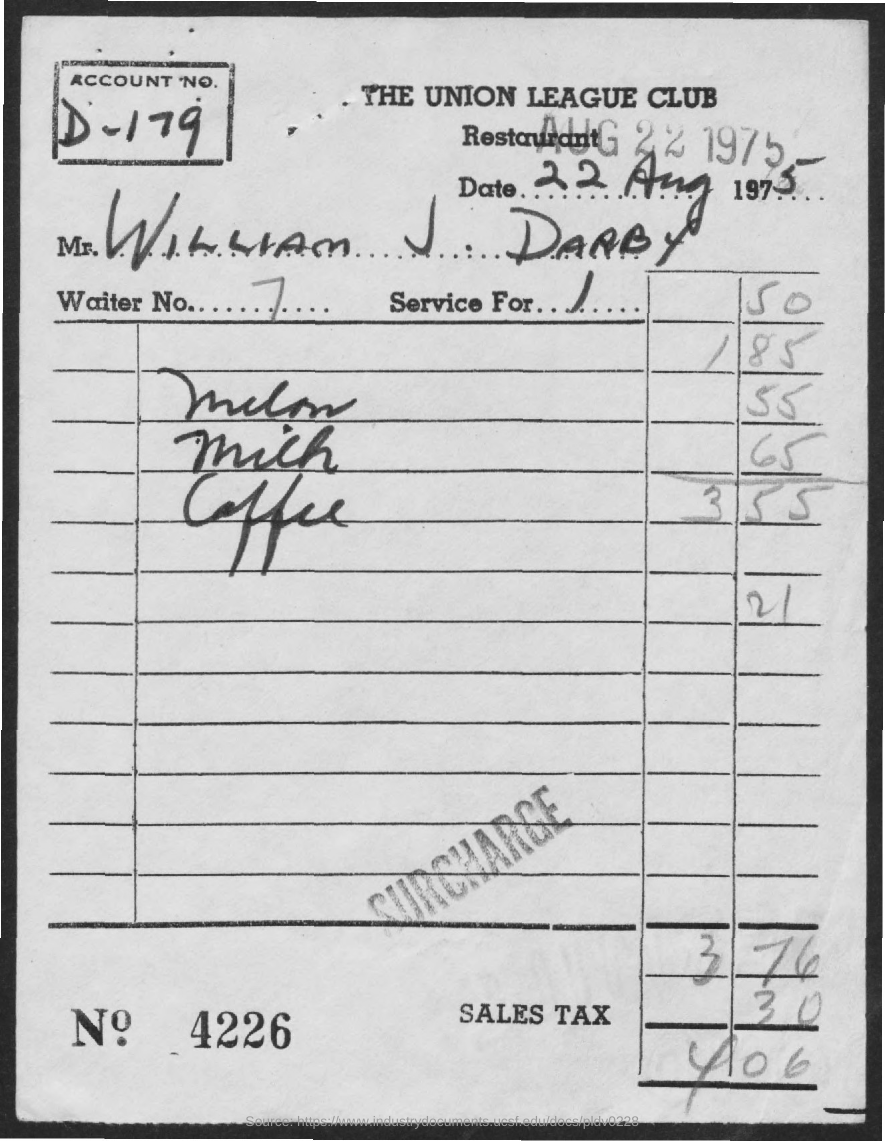Point out several critical features in this image. The bill given is for the Union League Club restaurant. The account number provided in the bill is D-179. The waiter provided a bill with a total of seven dollars and... 